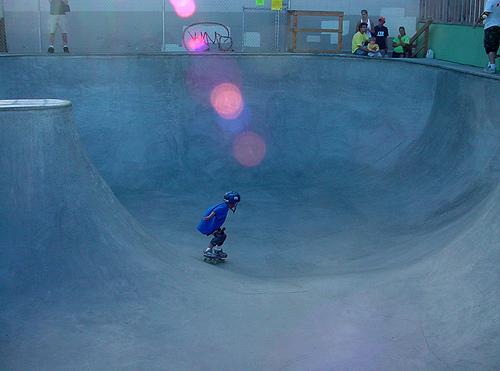Does he have on the proper attire to be skateboarding?
Concise answer only. Yes. What is the person on the left holding in his right hand?
Quick response, please. Skateboard. Are there red orbs falling from the sky?
Keep it brief. No. What is the dominant color?
Give a very brief answer. Blue. Did the skater fall?
Be succinct. No. How many people are skateboarding?
Write a very short answer. 1. Is this a warehouse?
Keep it brief. No. How many steps are to the right of the ramp?
Write a very short answer. 0. 